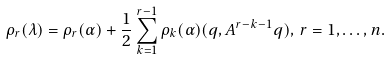Convert formula to latex. <formula><loc_0><loc_0><loc_500><loc_500>\rho _ { r } ( \lambda ) = \rho _ { r } ( \alpha ) + \frac { 1 } { 2 } \sum _ { k = 1 } ^ { r - 1 } \rho _ { k } ( \alpha ) ( q , A ^ { r - k - 1 } q ) , \, r = 1 , \dots , n .</formula> 